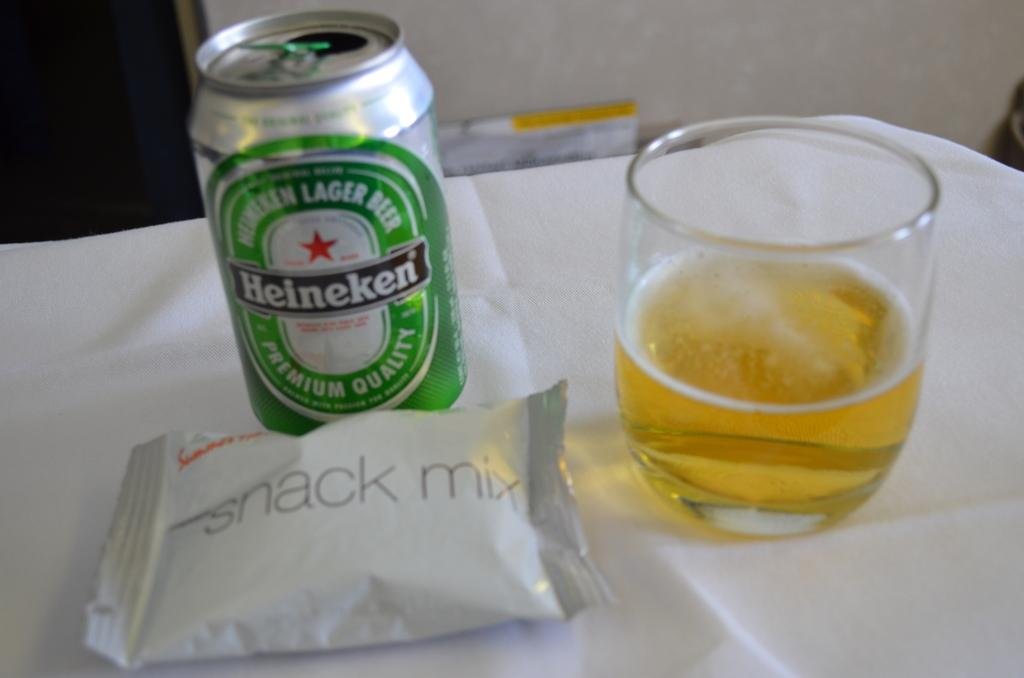<image>
Create a compact narrative representing the image presented. A airline tray contains snack mix and Heineken beer. 